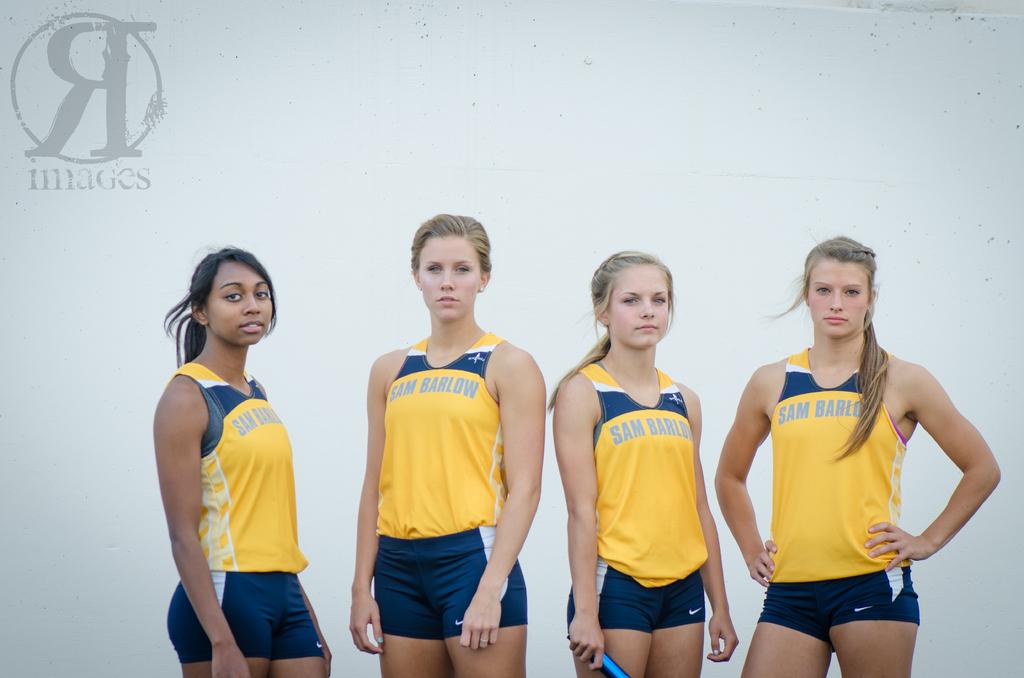What team do they play for?
Give a very brief answer. Sam barlow. What brand are the shorts?
Make the answer very short. Nike. 